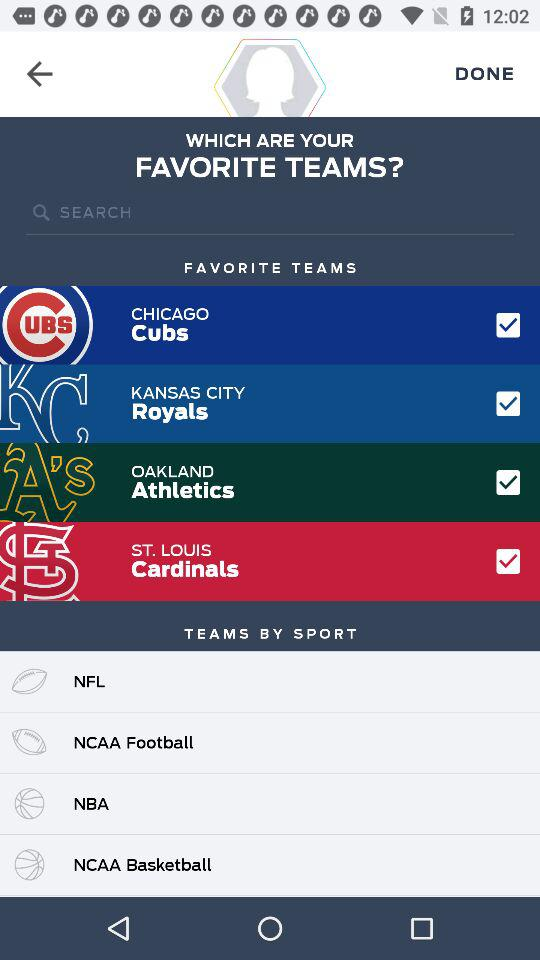How many teams are favorited?
Answer the question using a single word or phrase. 4 